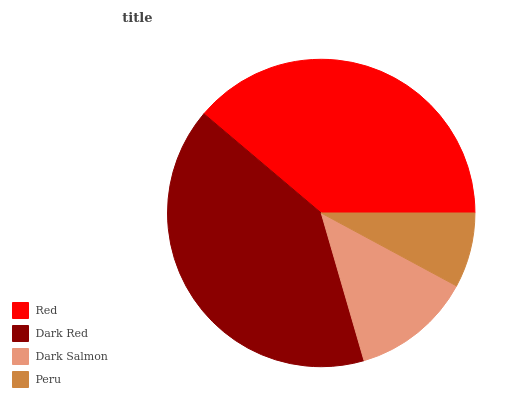Is Peru the minimum?
Answer yes or no. Yes. Is Dark Red the maximum?
Answer yes or no. Yes. Is Dark Salmon the minimum?
Answer yes or no. No. Is Dark Salmon the maximum?
Answer yes or no. No. Is Dark Red greater than Dark Salmon?
Answer yes or no. Yes. Is Dark Salmon less than Dark Red?
Answer yes or no. Yes. Is Dark Salmon greater than Dark Red?
Answer yes or no. No. Is Dark Red less than Dark Salmon?
Answer yes or no. No. Is Red the high median?
Answer yes or no. Yes. Is Dark Salmon the low median?
Answer yes or no. Yes. Is Peru the high median?
Answer yes or no. No. Is Peru the low median?
Answer yes or no. No. 